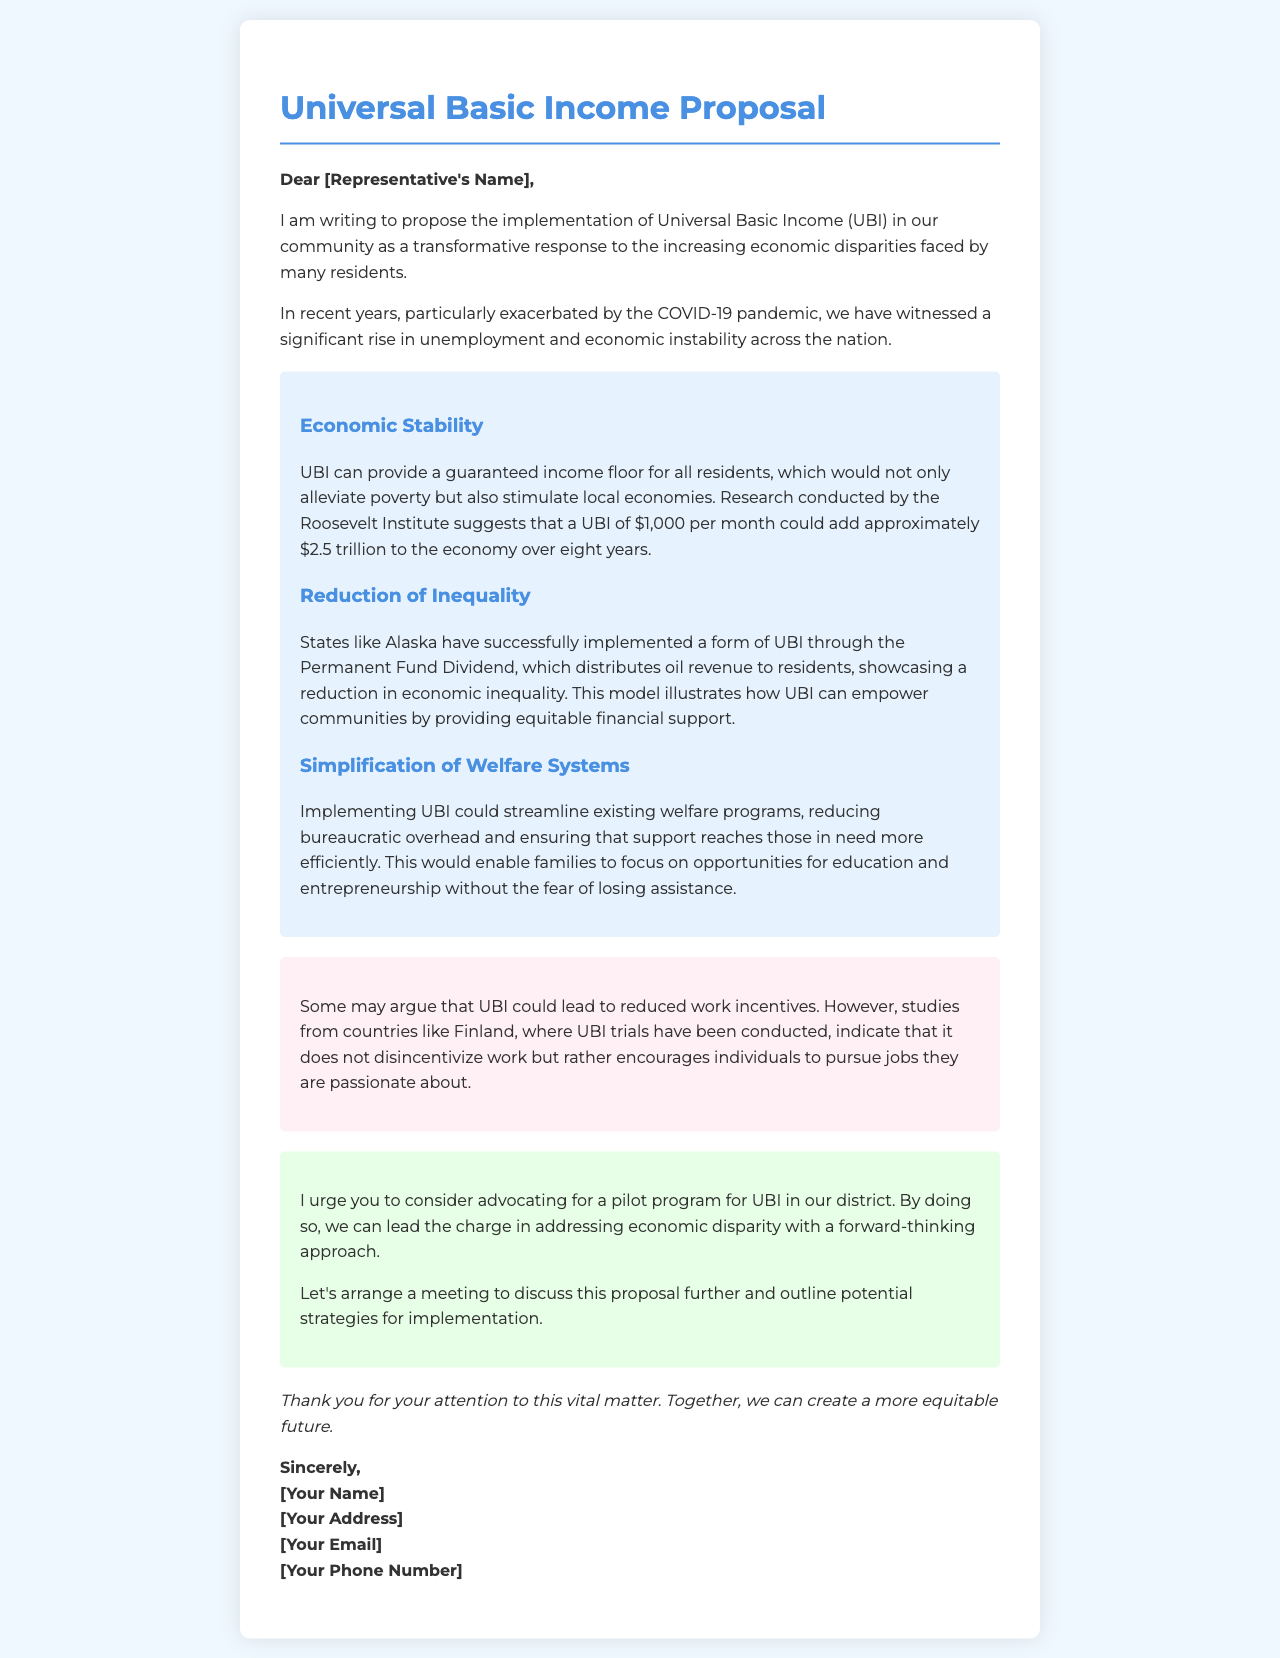What is the proposed monthly UBI amount? The proposed monthly UBI amount mentioned in the document is $1,000.
Answer: $1,000 What is the main purpose of the letter? The main purpose of the letter is to advocate for the implementation of Universal Basic Income in the community.
Answer: Advocate for UBI Which state is mentioned as having a successful UBI implementation? The state mentioned as having a successful UBI implementation is Alaska.
Answer: Alaska What large economic impact is anticipated from UBI implementation according to the Roosevelt Institute? The anticipated economic impact is approximately $2.5 trillion over eight years.
Answer: $2.5 trillion What is a counterargument addressed in the document? A counterargument addressed is that UBI could lead to reduced work incentives.
Answer: Reduced work incentives What is the urgency of the proposal in the letter? The urgency of the proposal is emphasized by urging the representative to consider advocating for a pilot program.
Answer: Urging for a pilot program What type of letter is this document classified as? This document is classified as a proposal letter.
Answer: Proposal letter What financial benefit does UBI provide to residents? UBI provides a guaranteed income floor for all residents.
Answer: Guaranteed income floor 